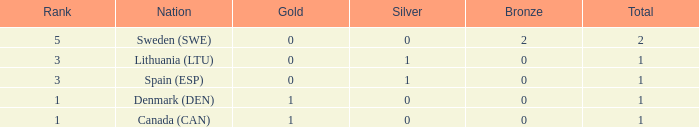What is the number of gold medals for Lithuania (ltu), when the total is more than 1? None. 